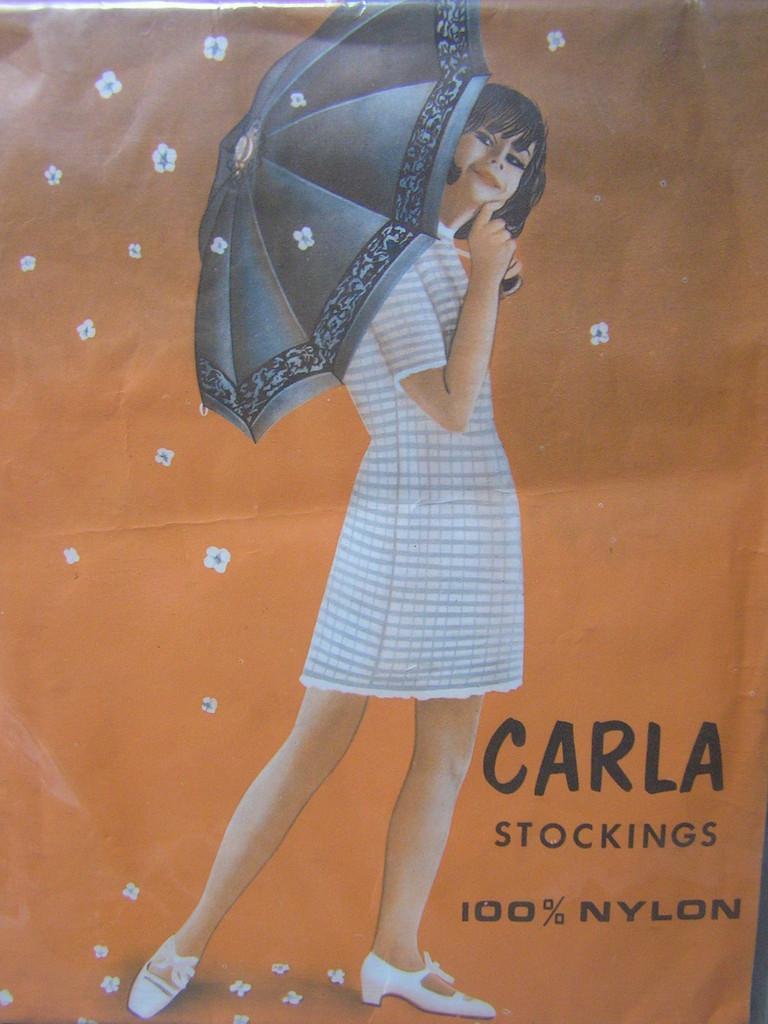Please provide a concise description of this image. This image is a painting. In the center of the image we can see girl holding umbrella. At the bottom right corner there is text. 